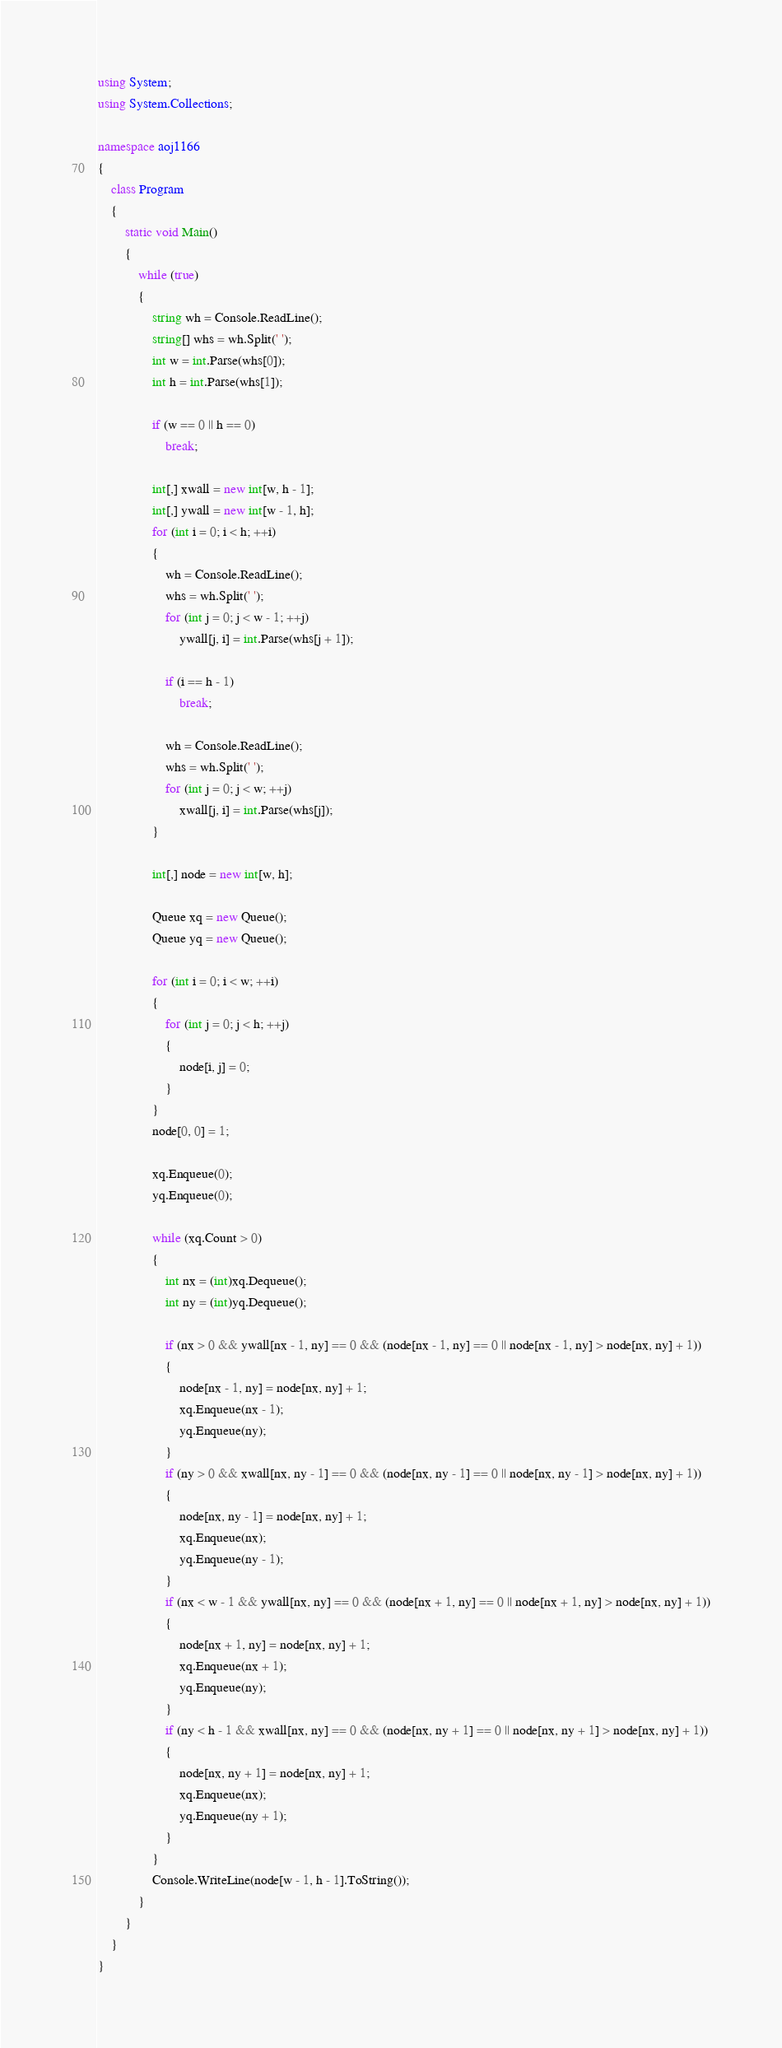<code> <loc_0><loc_0><loc_500><loc_500><_C#_>using System;
using System.Collections;

namespace aoj1166
{
    class Program
    {
        static void Main()
        {
            while (true)
            {
                string wh = Console.ReadLine();
                string[] whs = wh.Split(' ');
                int w = int.Parse(whs[0]);
                int h = int.Parse(whs[1]);
                
                if (w == 0 || h == 0)
                    break;

                int[,] xwall = new int[w, h - 1];
                int[,] ywall = new int[w - 1, h];
                for (int i = 0; i < h; ++i)
                {
                    wh = Console.ReadLine();
                    whs = wh.Split(' ');
                    for (int j = 0; j < w - 1; ++j) 
                        ywall[j, i] = int.Parse(whs[j + 1]);

                    if (i == h - 1)
                        break;

                    wh = Console.ReadLine();
                    whs = wh.Split(' ');
                    for (int j = 0; j < w; ++j)
                        xwall[j, i] = int.Parse(whs[j]);
                }

                int[,] node = new int[w, h];
                
                Queue xq = new Queue();
                Queue yq = new Queue();
                
                for (int i = 0; i < w; ++i) 
                {
                    for (int j = 0; j < h; ++j) 
                    {
                        node[i, j] = 0;
                    }
                }
                node[0, 0] = 1;
                
                xq.Enqueue(0);
                yq.Enqueue(0);

                while (xq.Count > 0) 
                {
                    int nx = (int)xq.Dequeue();
                    int ny = (int)yq.Dequeue();

                    if (nx > 0 && ywall[nx - 1, ny] == 0 && (node[nx - 1, ny] == 0 || node[nx - 1, ny] > node[nx, ny] + 1)) 
                    {
                        node[nx - 1, ny] = node[nx, ny] + 1;
                        xq.Enqueue(nx - 1);
                        yq.Enqueue(ny);
                    }
                    if (ny > 0 && xwall[nx, ny - 1] == 0 && (node[nx, ny - 1] == 0 || node[nx, ny - 1] > node[nx, ny] + 1))
                    {
                        node[nx, ny - 1] = node[nx, ny] + 1;
                        xq.Enqueue(nx);
                        yq.Enqueue(ny - 1);
                    }
                    if (nx < w - 1 && ywall[nx, ny] == 0 && (node[nx + 1, ny] == 0 || node[nx + 1, ny] > node[nx, ny] + 1))
                    {
                        node[nx + 1, ny] = node[nx, ny] + 1;
                        xq.Enqueue(nx + 1);
                        yq.Enqueue(ny);
                    }
                    if (ny < h - 1 && xwall[nx, ny] == 0 && (node[nx, ny + 1] == 0 || node[nx, ny + 1] > node[nx, ny] + 1))
                    {
                        node[nx, ny + 1] = node[nx, ny] + 1;
                        xq.Enqueue(nx);
                        yq.Enqueue(ny + 1);
                    }
                }
                Console.WriteLine(node[w - 1, h - 1].ToString());
            }
        }
    }
}</code> 